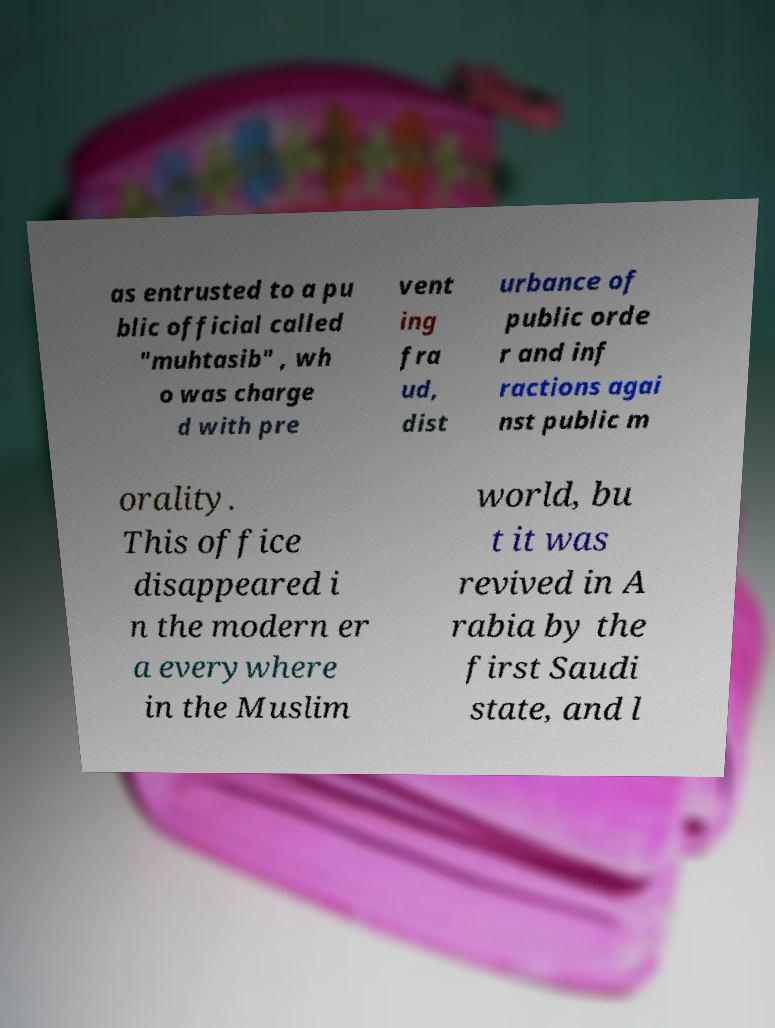For documentation purposes, I need the text within this image transcribed. Could you provide that? as entrusted to a pu blic official called "muhtasib" , wh o was charge d with pre vent ing fra ud, dist urbance of public orde r and inf ractions agai nst public m orality. This office disappeared i n the modern er a everywhere in the Muslim world, bu t it was revived in A rabia by the first Saudi state, and l 